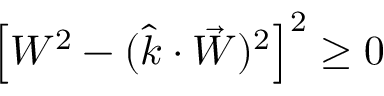<formula> <loc_0><loc_0><loc_500><loc_500>\left [ W ^ { 2 } - ( \hat { k } \cdot \vec { W } ) ^ { 2 } \right ] ^ { 2 } \geq 0</formula> 